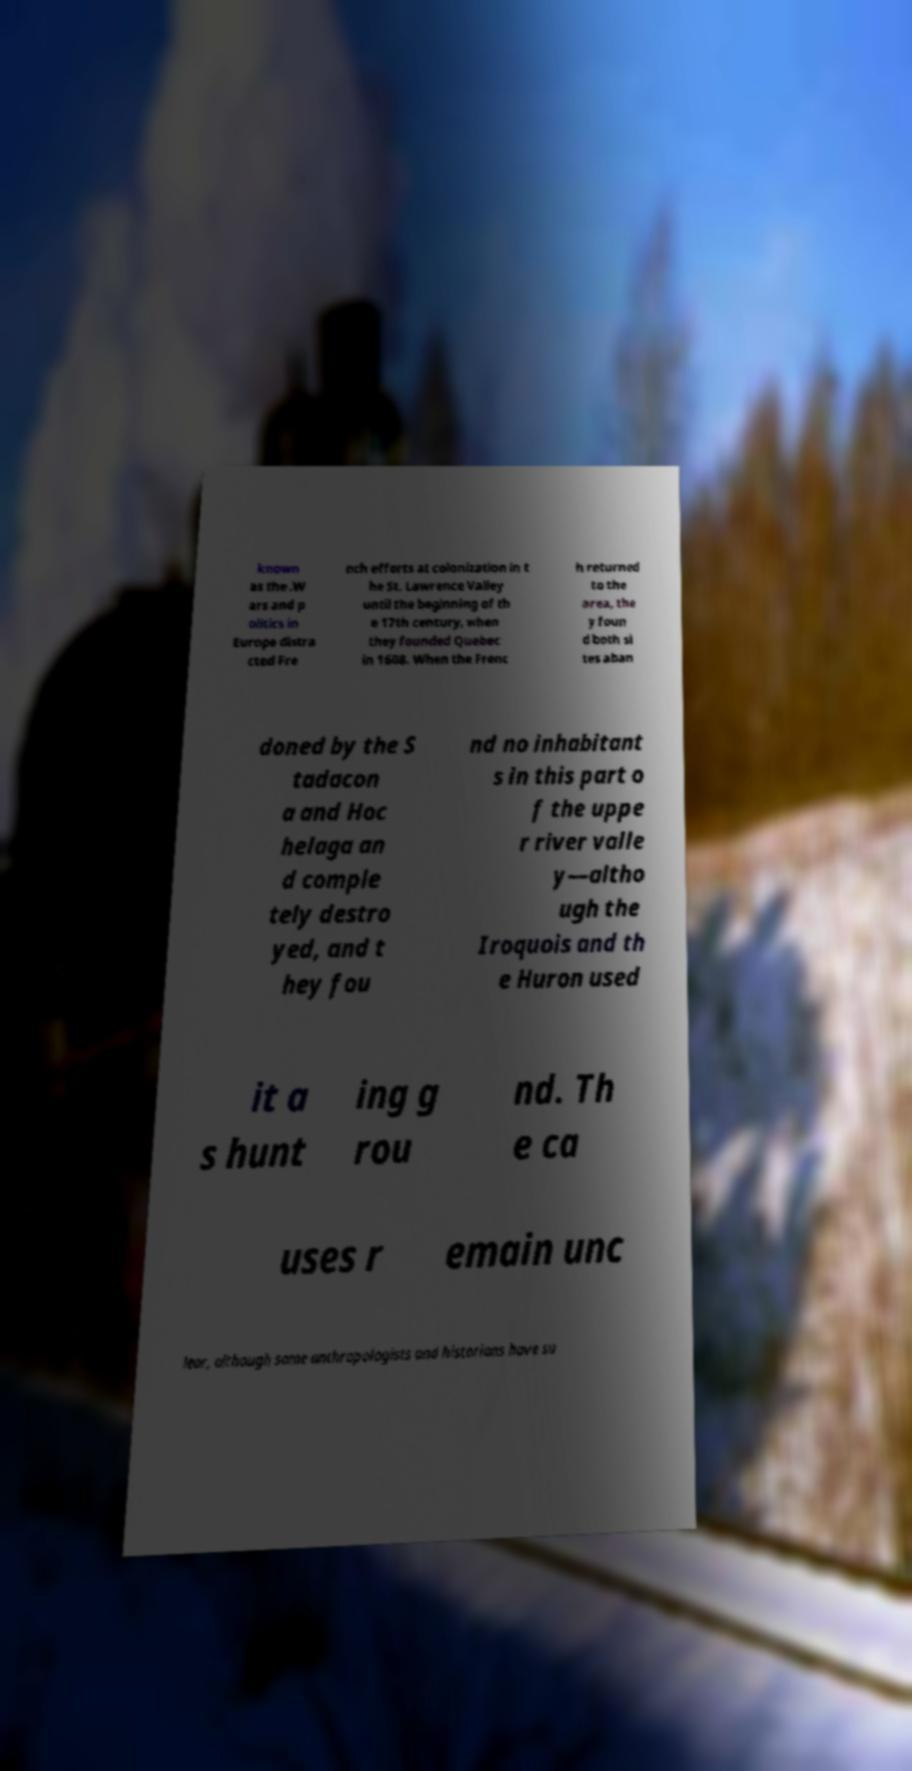I need the written content from this picture converted into text. Can you do that? known as the .W ars and p olitics in Europe distra cted Fre nch efforts at colonization in t he St. Lawrence Valley until the beginning of th e 17th century, when they founded Quebec in 1608. When the Frenc h returned to the area, the y foun d both si tes aban doned by the S tadacon a and Hoc helaga an d comple tely destro yed, and t hey fou nd no inhabitant s in this part o f the uppe r river valle y—altho ugh the Iroquois and th e Huron used it a s hunt ing g rou nd. Th e ca uses r emain unc lear, although some anthropologists and historians have su 